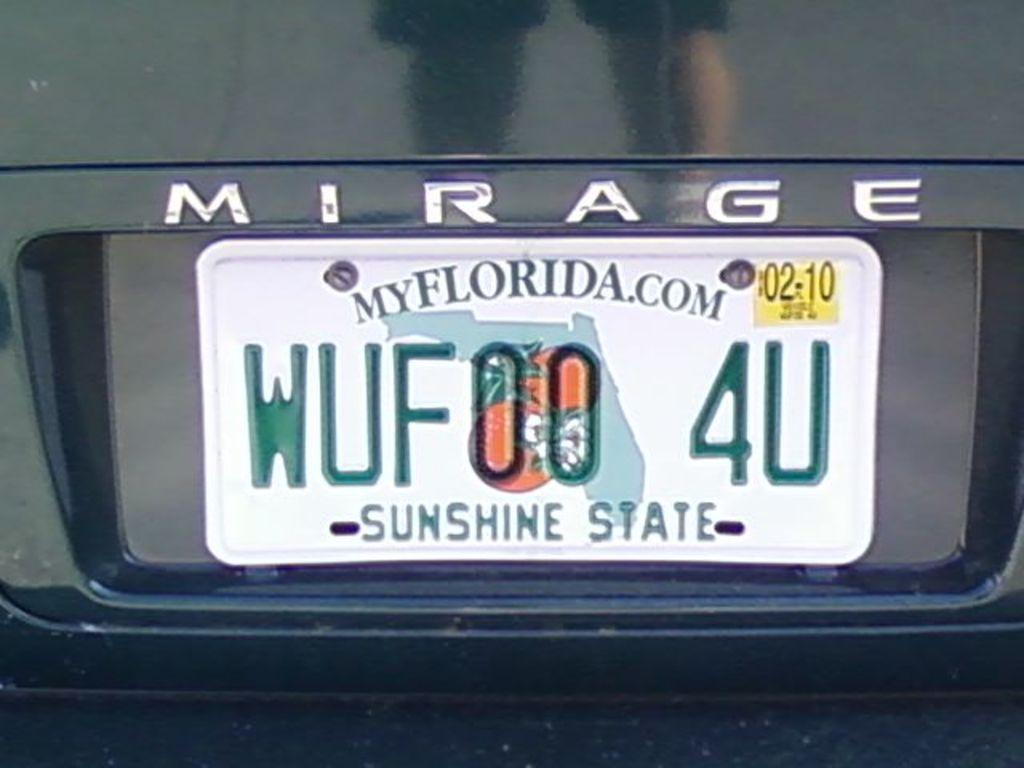<image>
Relay a brief, clear account of the picture shown. Florida license on a Mirage is shown up close. 